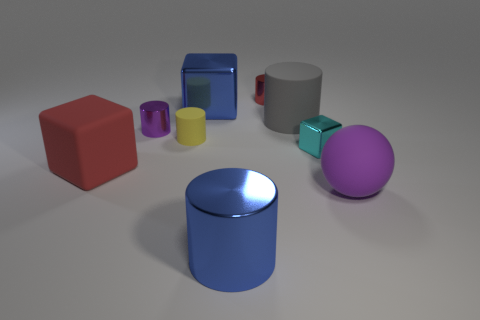Subtract all small yellow matte cylinders. How many cylinders are left? 4 Subtract all gray cylinders. How many cylinders are left? 4 Subtract all brown cylinders. Subtract all yellow blocks. How many cylinders are left? 5 Add 1 tiny cyan things. How many objects exist? 10 Subtract all cylinders. How many objects are left? 4 Subtract 0 brown cylinders. How many objects are left? 9 Subtract all gray rubber things. Subtract all blue metal blocks. How many objects are left? 7 Add 7 small rubber cylinders. How many small rubber cylinders are left? 8 Add 1 small red objects. How many small red objects exist? 2 